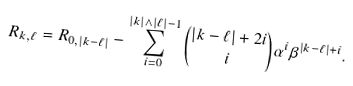<formula> <loc_0><loc_0><loc_500><loc_500>R _ { k , \ell } = R _ { 0 , | k - \ell | } - \sum _ { i = 0 } ^ { | k | \land | \ell | - 1 } \binom { | k - \ell | + 2 i } { i } \alpha ^ { i } \beta ^ { | k - \ell | + i } .</formula> 